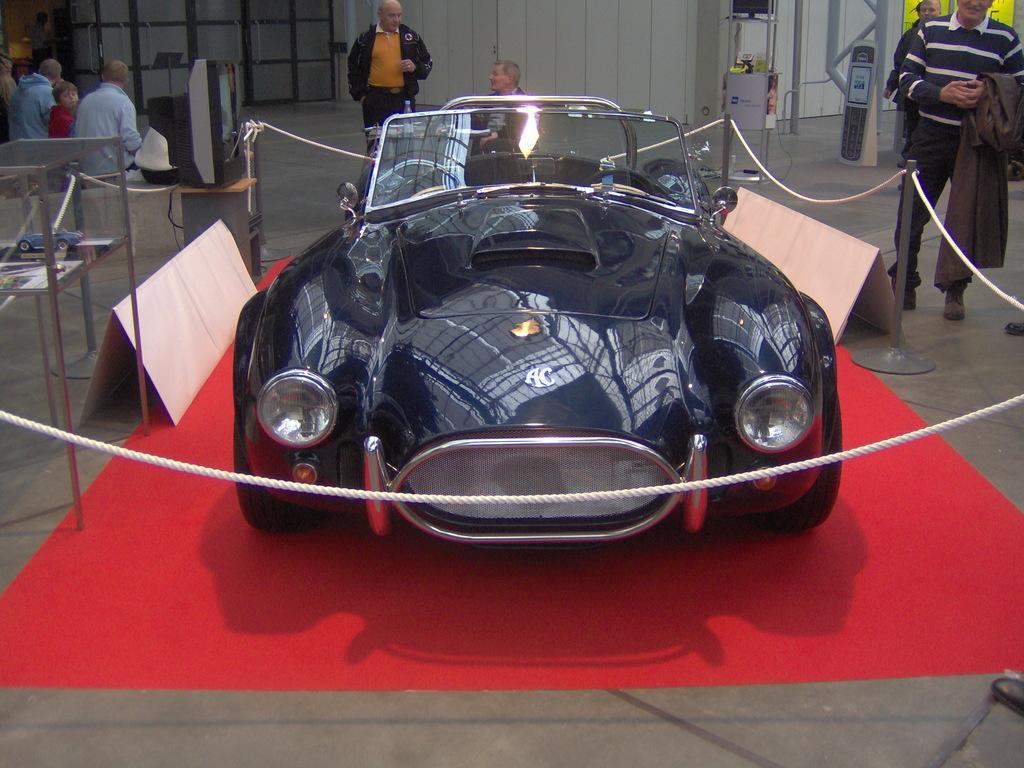Please provide a concise description of this image. In the center of the picture there is a car, around the car there are ropes, stands and boards. On the right people there are people standing. In the center of the background there are people and wall. On the left there are people sitting. At the top there are some iron frames, television and other objects. In the foreground there is a red carpet. 